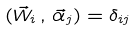<formula> <loc_0><loc_0><loc_500><loc_500>( { \vec { W } } _ { i } \, , \, { \vec { \alpha } } _ { j } ) = \delta _ { i j }</formula> 